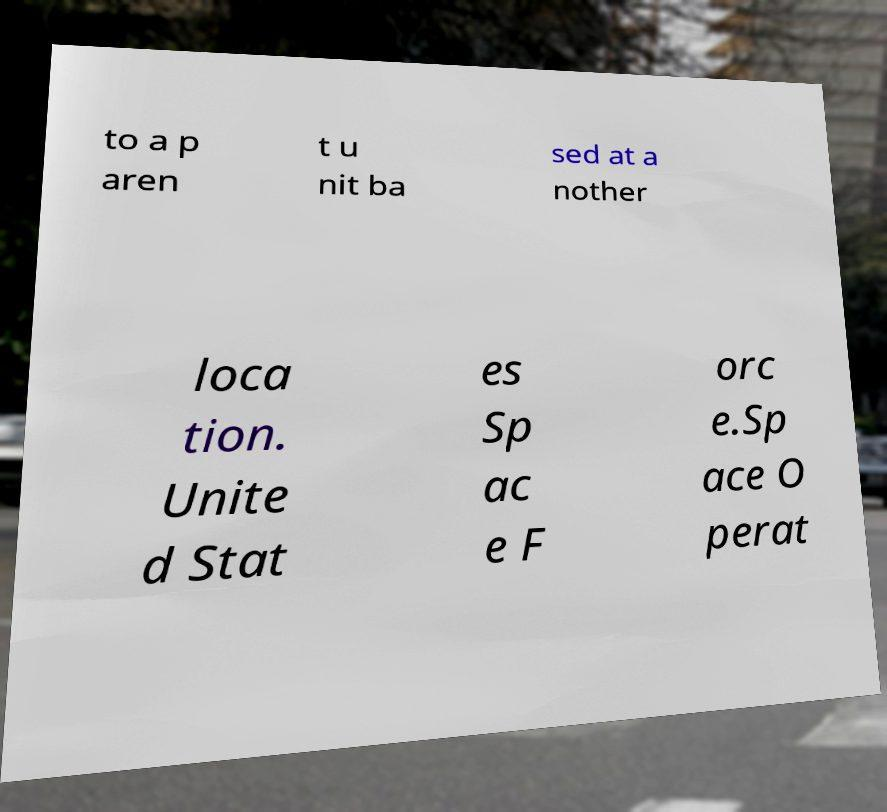Can you accurately transcribe the text from the provided image for me? to a p aren t u nit ba sed at a nother loca tion. Unite d Stat es Sp ac e F orc e.Sp ace O perat 